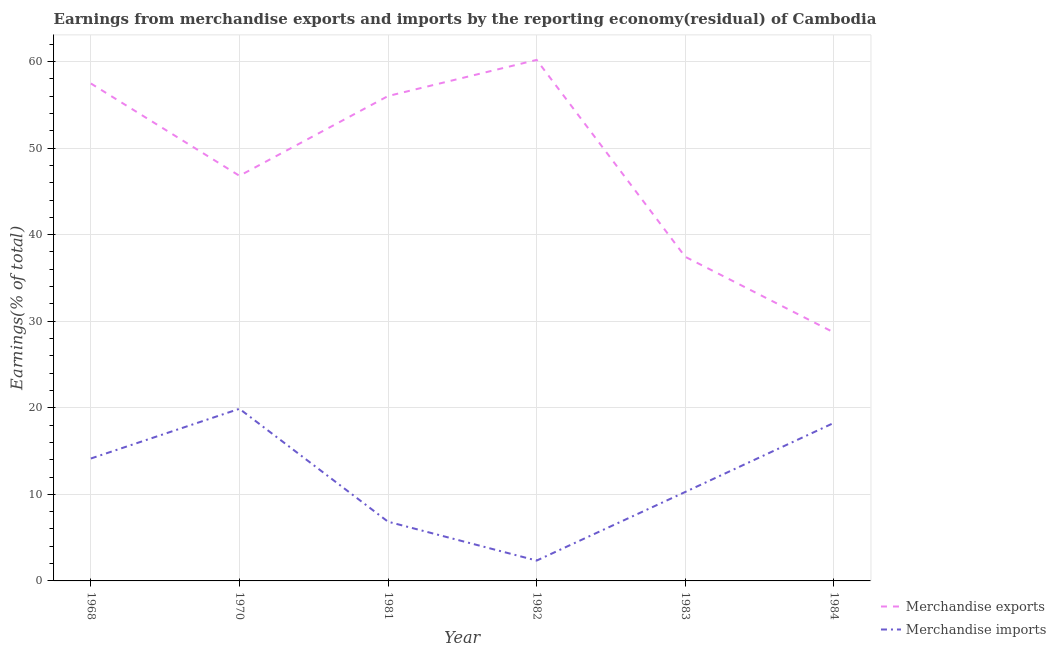Does the line corresponding to earnings from merchandise imports intersect with the line corresponding to earnings from merchandise exports?
Provide a short and direct response. No. Is the number of lines equal to the number of legend labels?
Provide a short and direct response. Yes. What is the earnings from merchandise imports in 1968?
Make the answer very short. 14.14. Across all years, what is the maximum earnings from merchandise imports?
Offer a very short reply. 19.88. Across all years, what is the minimum earnings from merchandise imports?
Ensure brevity in your answer.  2.35. In which year was the earnings from merchandise exports maximum?
Ensure brevity in your answer.  1982. What is the total earnings from merchandise exports in the graph?
Offer a very short reply. 286.62. What is the difference between the earnings from merchandise imports in 1970 and that in 1983?
Your answer should be compact. 9.61. What is the difference between the earnings from merchandise imports in 1970 and the earnings from merchandise exports in 1981?
Provide a short and direct response. -36.13. What is the average earnings from merchandise imports per year?
Keep it short and to the point. 11.96. In the year 1984, what is the difference between the earnings from merchandise imports and earnings from merchandise exports?
Your answer should be very brief. -10.45. What is the ratio of the earnings from merchandise exports in 1968 to that in 1981?
Ensure brevity in your answer.  1.03. Is the earnings from merchandise imports in 1968 less than that in 1970?
Your response must be concise. Yes. Is the difference between the earnings from merchandise exports in 1968 and 1970 greater than the difference between the earnings from merchandise imports in 1968 and 1970?
Offer a very short reply. Yes. What is the difference between the highest and the second highest earnings from merchandise imports?
Your answer should be very brief. 1.63. What is the difference between the highest and the lowest earnings from merchandise imports?
Provide a short and direct response. 17.53. Is the sum of the earnings from merchandise imports in 1983 and 1984 greater than the maximum earnings from merchandise exports across all years?
Provide a short and direct response. No. Is the earnings from merchandise imports strictly greater than the earnings from merchandise exports over the years?
Make the answer very short. No. Does the graph contain grids?
Provide a short and direct response. Yes. What is the title of the graph?
Your response must be concise. Earnings from merchandise exports and imports by the reporting economy(residual) of Cambodia. What is the label or title of the Y-axis?
Make the answer very short. Earnings(% of total). What is the Earnings(% of total) in Merchandise exports in 1968?
Offer a very short reply. 57.47. What is the Earnings(% of total) in Merchandise imports in 1968?
Offer a terse response. 14.14. What is the Earnings(% of total) in Merchandise exports in 1970?
Your answer should be compact. 46.8. What is the Earnings(% of total) in Merchandise imports in 1970?
Your answer should be very brief. 19.88. What is the Earnings(% of total) in Merchandise exports in 1981?
Give a very brief answer. 56.02. What is the Earnings(% of total) of Merchandise imports in 1981?
Provide a succinct answer. 6.84. What is the Earnings(% of total) in Merchandise exports in 1982?
Ensure brevity in your answer.  60.19. What is the Earnings(% of total) of Merchandise imports in 1982?
Make the answer very short. 2.35. What is the Earnings(% of total) of Merchandise exports in 1983?
Ensure brevity in your answer.  37.44. What is the Earnings(% of total) in Merchandise imports in 1983?
Your answer should be very brief. 10.28. What is the Earnings(% of total) in Merchandise exports in 1984?
Ensure brevity in your answer.  28.71. What is the Earnings(% of total) of Merchandise imports in 1984?
Offer a terse response. 18.25. Across all years, what is the maximum Earnings(% of total) in Merchandise exports?
Your response must be concise. 60.19. Across all years, what is the maximum Earnings(% of total) of Merchandise imports?
Provide a succinct answer. 19.88. Across all years, what is the minimum Earnings(% of total) in Merchandise exports?
Make the answer very short. 28.71. Across all years, what is the minimum Earnings(% of total) of Merchandise imports?
Your answer should be very brief. 2.35. What is the total Earnings(% of total) in Merchandise exports in the graph?
Provide a succinct answer. 286.62. What is the total Earnings(% of total) of Merchandise imports in the graph?
Ensure brevity in your answer.  71.75. What is the difference between the Earnings(% of total) in Merchandise exports in 1968 and that in 1970?
Provide a succinct answer. 10.67. What is the difference between the Earnings(% of total) of Merchandise imports in 1968 and that in 1970?
Offer a terse response. -5.74. What is the difference between the Earnings(% of total) in Merchandise exports in 1968 and that in 1981?
Give a very brief answer. 1.45. What is the difference between the Earnings(% of total) in Merchandise imports in 1968 and that in 1981?
Ensure brevity in your answer.  7.3. What is the difference between the Earnings(% of total) of Merchandise exports in 1968 and that in 1982?
Offer a very short reply. -2.72. What is the difference between the Earnings(% of total) in Merchandise imports in 1968 and that in 1982?
Provide a succinct answer. 11.79. What is the difference between the Earnings(% of total) in Merchandise exports in 1968 and that in 1983?
Offer a very short reply. 20.02. What is the difference between the Earnings(% of total) of Merchandise imports in 1968 and that in 1983?
Offer a terse response. 3.87. What is the difference between the Earnings(% of total) in Merchandise exports in 1968 and that in 1984?
Keep it short and to the point. 28.76. What is the difference between the Earnings(% of total) in Merchandise imports in 1968 and that in 1984?
Offer a very short reply. -4.11. What is the difference between the Earnings(% of total) of Merchandise exports in 1970 and that in 1981?
Provide a succinct answer. -9.21. What is the difference between the Earnings(% of total) in Merchandise imports in 1970 and that in 1981?
Give a very brief answer. 13.04. What is the difference between the Earnings(% of total) in Merchandise exports in 1970 and that in 1982?
Make the answer very short. -13.39. What is the difference between the Earnings(% of total) in Merchandise imports in 1970 and that in 1982?
Provide a succinct answer. 17.53. What is the difference between the Earnings(% of total) of Merchandise exports in 1970 and that in 1983?
Ensure brevity in your answer.  9.36. What is the difference between the Earnings(% of total) of Merchandise imports in 1970 and that in 1983?
Make the answer very short. 9.61. What is the difference between the Earnings(% of total) in Merchandise exports in 1970 and that in 1984?
Keep it short and to the point. 18.1. What is the difference between the Earnings(% of total) in Merchandise imports in 1970 and that in 1984?
Offer a terse response. 1.63. What is the difference between the Earnings(% of total) in Merchandise exports in 1981 and that in 1982?
Keep it short and to the point. -4.17. What is the difference between the Earnings(% of total) in Merchandise imports in 1981 and that in 1982?
Ensure brevity in your answer.  4.49. What is the difference between the Earnings(% of total) of Merchandise exports in 1981 and that in 1983?
Your response must be concise. 18.57. What is the difference between the Earnings(% of total) in Merchandise imports in 1981 and that in 1983?
Ensure brevity in your answer.  -3.44. What is the difference between the Earnings(% of total) in Merchandise exports in 1981 and that in 1984?
Your answer should be compact. 27.31. What is the difference between the Earnings(% of total) of Merchandise imports in 1981 and that in 1984?
Give a very brief answer. -11.41. What is the difference between the Earnings(% of total) in Merchandise exports in 1982 and that in 1983?
Your response must be concise. 22.74. What is the difference between the Earnings(% of total) of Merchandise imports in 1982 and that in 1983?
Offer a very short reply. -7.93. What is the difference between the Earnings(% of total) in Merchandise exports in 1982 and that in 1984?
Offer a terse response. 31.48. What is the difference between the Earnings(% of total) in Merchandise imports in 1982 and that in 1984?
Provide a short and direct response. -15.9. What is the difference between the Earnings(% of total) in Merchandise exports in 1983 and that in 1984?
Your answer should be very brief. 8.74. What is the difference between the Earnings(% of total) of Merchandise imports in 1983 and that in 1984?
Offer a very short reply. -7.98. What is the difference between the Earnings(% of total) of Merchandise exports in 1968 and the Earnings(% of total) of Merchandise imports in 1970?
Provide a short and direct response. 37.58. What is the difference between the Earnings(% of total) of Merchandise exports in 1968 and the Earnings(% of total) of Merchandise imports in 1981?
Keep it short and to the point. 50.63. What is the difference between the Earnings(% of total) in Merchandise exports in 1968 and the Earnings(% of total) in Merchandise imports in 1982?
Provide a succinct answer. 55.12. What is the difference between the Earnings(% of total) in Merchandise exports in 1968 and the Earnings(% of total) in Merchandise imports in 1983?
Keep it short and to the point. 47.19. What is the difference between the Earnings(% of total) in Merchandise exports in 1968 and the Earnings(% of total) in Merchandise imports in 1984?
Your answer should be compact. 39.22. What is the difference between the Earnings(% of total) of Merchandise exports in 1970 and the Earnings(% of total) of Merchandise imports in 1981?
Your response must be concise. 39.96. What is the difference between the Earnings(% of total) in Merchandise exports in 1970 and the Earnings(% of total) in Merchandise imports in 1982?
Provide a succinct answer. 44.45. What is the difference between the Earnings(% of total) in Merchandise exports in 1970 and the Earnings(% of total) in Merchandise imports in 1983?
Keep it short and to the point. 36.52. What is the difference between the Earnings(% of total) in Merchandise exports in 1970 and the Earnings(% of total) in Merchandise imports in 1984?
Ensure brevity in your answer.  28.55. What is the difference between the Earnings(% of total) of Merchandise exports in 1981 and the Earnings(% of total) of Merchandise imports in 1982?
Ensure brevity in your answer.  53.66. What is the difference between the Earnings(% of total) of Merchandise exports in 1981 and the Earnings(% of total) of Merchandise imports in 1983?
Provide a succinct answer. 45.74. What is the difference between the Earnings(% of total) in Merchandise exports in 1981 and the Earnings(% of total) in Merchandise imports in 1984?
Give a very brief answer. 37.76. What is the difference between the Earnings(% of total) in Merchandise exports in 1982 and the Earnings(% of total) in Merchandise imports in 1983?
Offer a very short reply. 49.91. What is the difference between the Earnings(% of total) in Merchandise exports in 1982 and the Earnings(% of total) in Merchandise imports in 1984?
Ensure brevity in your answer.  41.94. What is the difference between the Earnings(% of total) of Merchandise exports in 1983 and the Earnings(% of total) of Merchandise imports in 1984?
Provide a short and direct response. 19.19. What is the average Earnings(% of total) in Merchandise exports per year?
Offer a terse response. 47.77. What is the average Earnings(% of total) of Merchandise imports per year?
Make the answer very short. 11.96. In the year 1968, what is the difference between the Earnings(% of total) of Merchandise exports and Earnings(% of total) of Merchandise imports?
Give a very brief answer. 43.33. In the year 1970, what is the difference between the Earnings(% of total) in Merchandise exports and Earnings(% of total) in Merchandise imports?
Provide a short and direct response. 26.92. In the year 1981, what is the difference between the Earnings(% of total) of Merchandise exports and Earnings(% of total) of Merchandise imports?
Your answer should be compact. 49.17. In the year 1982, what is the difference between the Earnings(% of total) of Merchandise exports and Earnings(% of total) of Merchandise imports?
Keep it short and to the point. 57.84. In the year 1983, what is the difference between the Earnings(% of total) of Merchandise exports and Earnings(% of total) of Merchandise imports?
Provide a succinct answer. 27.17. In the year 1984, what is the difference between the Earnings(% of total) of Merchandise exports and Earnings(% of total) of Merchandise imports?
Provide a short and direct response. 10.45. What is the ratio of the Earnings(% of total) of Merchandise exports in 1968 to that in 1970?
Make the answer very short. 1.23. What is the ratio of the Earnings(% of total) in Merchandise imports in 1968 to that in 1970?
Your answer should be very brief. 0.71. What is the ratio of the Earnings(% of total) of Merchandise exports in 1968 to that in 1981?
Your response must be concise. 1.03. What is the ratio of the Earnings(% of total) of Merchandise imports in 1968 to that in 1981?
Provide a short and direct response. 2.07. What is the ratio of the Earnings(% of total) in Merchandise exports in 1968 to that in 1982?
Make the answer very short. 0.95. What is the ratio of the Earnings(% of total) in Merchandise imports in 1968 to that in 1982?
Ensure brevity in your answer.  6.02. What is the ratio of the Earnings(% of total) in Merchandise exports in 1968 to that in 1983?
Give a very brief answer. 1.53. What is the ratio of the Earnings(% of total) in Merchandise imports in 1968 to that in 1983?
Offer a terse response. 1.38. What is the ratio of the Earnings(% of total) of Merchandise exports in 1968 to that in 1984?
Offer a very short reply. 2. What is the ratio of the Earnings(% of total) in Merchandise imports in 1968 to that in 1984?
Make the answer very short. 0.77. What is the ratio of the Earnings(% of total) in Merchandise exports in 1970 to that in 1981?
Your response must be concise. 0.84. What is the ratio of the Earnings(% of total) in Merchandise imports in 1970 to that in 1981?
Provide a succinct answer. 2.91. What is the ratio of the Earnings(% of total) in Merchandise exports in 1970 to that in 1982?
Provide a succinct answer. 0.78. What is the ratio of the Earnings(% of total) in Merchandise imports in 1970 to that in 1982?
Keep it short and to the point. 8.46. What is the ratio of the Earnings(% of total) of Merchandise exports in 1970 to that in 1983?
Offer a very short reply. 1.25. What is the ratio of the Earnings(% of total) in Merchandise imports in 1970 to that in 1983?
Provide a succinct answer. 1.94. What is the ratio of the Earnings(% of total) of Merchandise exports in 1970 to that in 1984?
Make the answer very short. 1.63. What is the ratio of the Earnings(% of total) in Merchandise imports in 1970 to that in 1984?
Provide a succinct answer. 1.09. What is the ratio of the Earnings(% of total) in Merchandise exports in 1981 to that in 1982?
Your response must be concise. 0.93. What is the ratio of the Earnings(% of total) of Merchandise imports in 1981 to that in 1982?
Your answer should be very brief. 2.91. What is the ratio of the Earnings(% of total) of Merchandise exports in 1981 to that in 1983?
Provide a short and direct response. 1.5. What is the ratio of the Earnings(% of total) of Merchandise imports in 1981 to that in 1983?
Ensure brevity in your answer.  0.67. What is the ratio of the Earnings(% of total) of Merchandise exports in 1981 to that in 1984?
Make the answer very short. 1.95. What is the ratio of the Earnings(% of total) of Merchandise imports in 1981 to that in 1984?
Your response must be concise. 0.37. What is the ratio of the Earnings(% of total) of Merchandise exports in 1982 to that in 1983?
Provide a succinct answer. 1.61. What is the ratio of the Earnings(% of total) in Merchandise imports in 1982 to that in 1983?
Your answer should be compact. 0.23. What is the ratio of the Earnings(% of total) of Merchandise exports in 1982 to that in 1984?
Offer a terse response. 2.1. What is the ratio of the Earnings(% of total) in Merchandise imports in 1982 to that in 1984?
Make the answer very short. 0.13. What is the ratio of the Earnings(% of total) in Merchandise exports in 1983 to that in 1984?
Provide a succinct answer. 1.3. What is the ratio of the Earnings(% of total) of Merchandise imports in 1983 to that in 1984?
Provide a succinct answer. 0.56. What is the difference between the highest and the second highest Earnings(% of total) of Merchandise exports?
Provide a succinct answer. 2.72. What is the difference between the highest and the second highest Earnings(% of total) in Merchandise imports?
Provide a succinct answer. 1.63. What is the difference between the highest and the lowest Earnings(% of total) of Merchandise exports?
Offer a terse response. 31.48. What is the difference between the highest and the lowest Earnings(% of total) of Merchandise imports?
Ensure brevity in your answer.  17.53. 